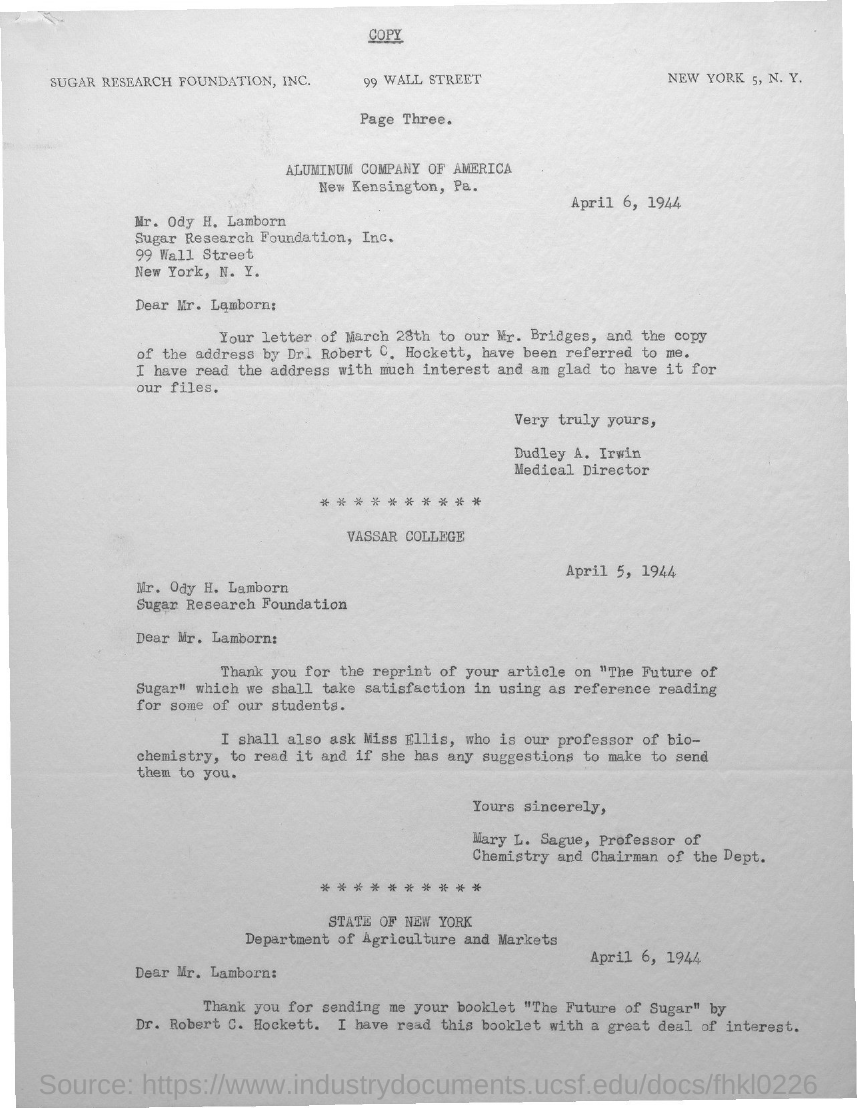Who is the sender of the first letter in this document?
Keep it short and to the point. Dudley A. Irwin. What is the designation of Dudley A. Irwin?
Your answer should be very brief. Medical Director. Who is the addressee of the first letter in this document?
Give a very brief answer. Mr. Lamborn:. What is the designation of Mary L. Sague?
Your response must be concise. Professor of Chemistry and Chairman of the Dept. What is the date mentioned in the first letter of this document?
Provide a succinct answer. April 6, 1944. 